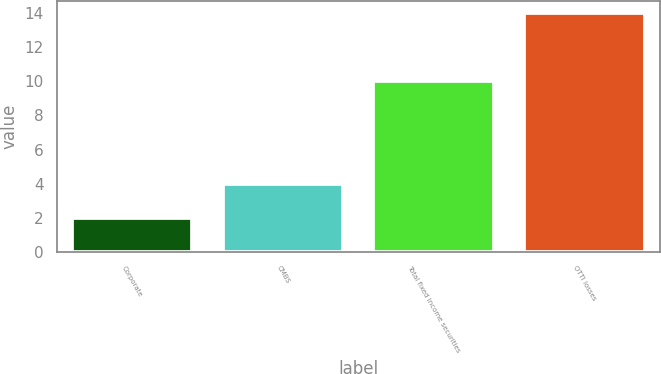Convert chart. <chart><loc_0><loc_0><loc_500><loc_500><bar_chart><fcel>Corporate<fcel>CMBS<fcel>Total fixed income securities<fcel>OTTI losses<nl><fcel>2<fcel>4<fcel>10<fcel>14<nl></chart> 